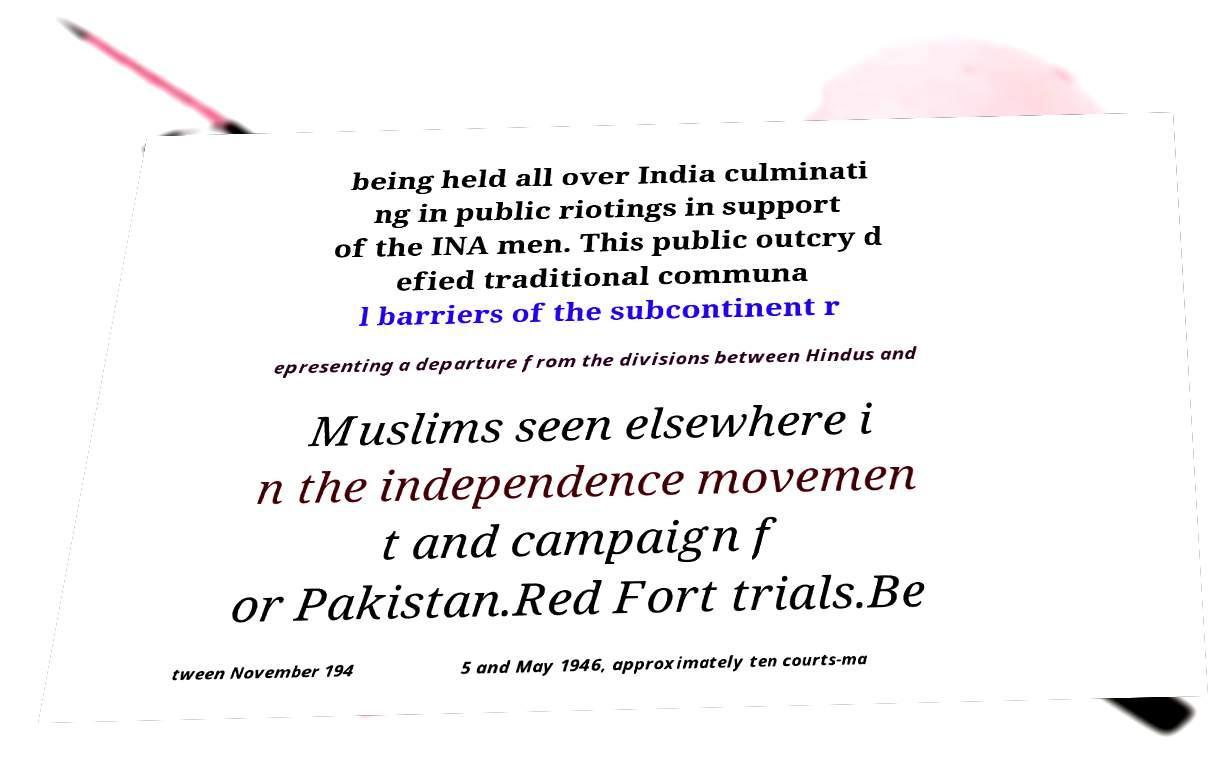What messages or text are displayed in this image? I need them in a readable, typed format. being held all over India culminati ng in public riotings in support of the INA men. This public outcry d efied traditional communa l barriers of the subcontinent r epresenting a departure from the divisions between Hindus and Muslims seen elsewhere i n the independence movemen t and campaign f or Pakistan.Red Fort trials.Be tween November 194 5 and May 1946, approximately ten courts-ma 